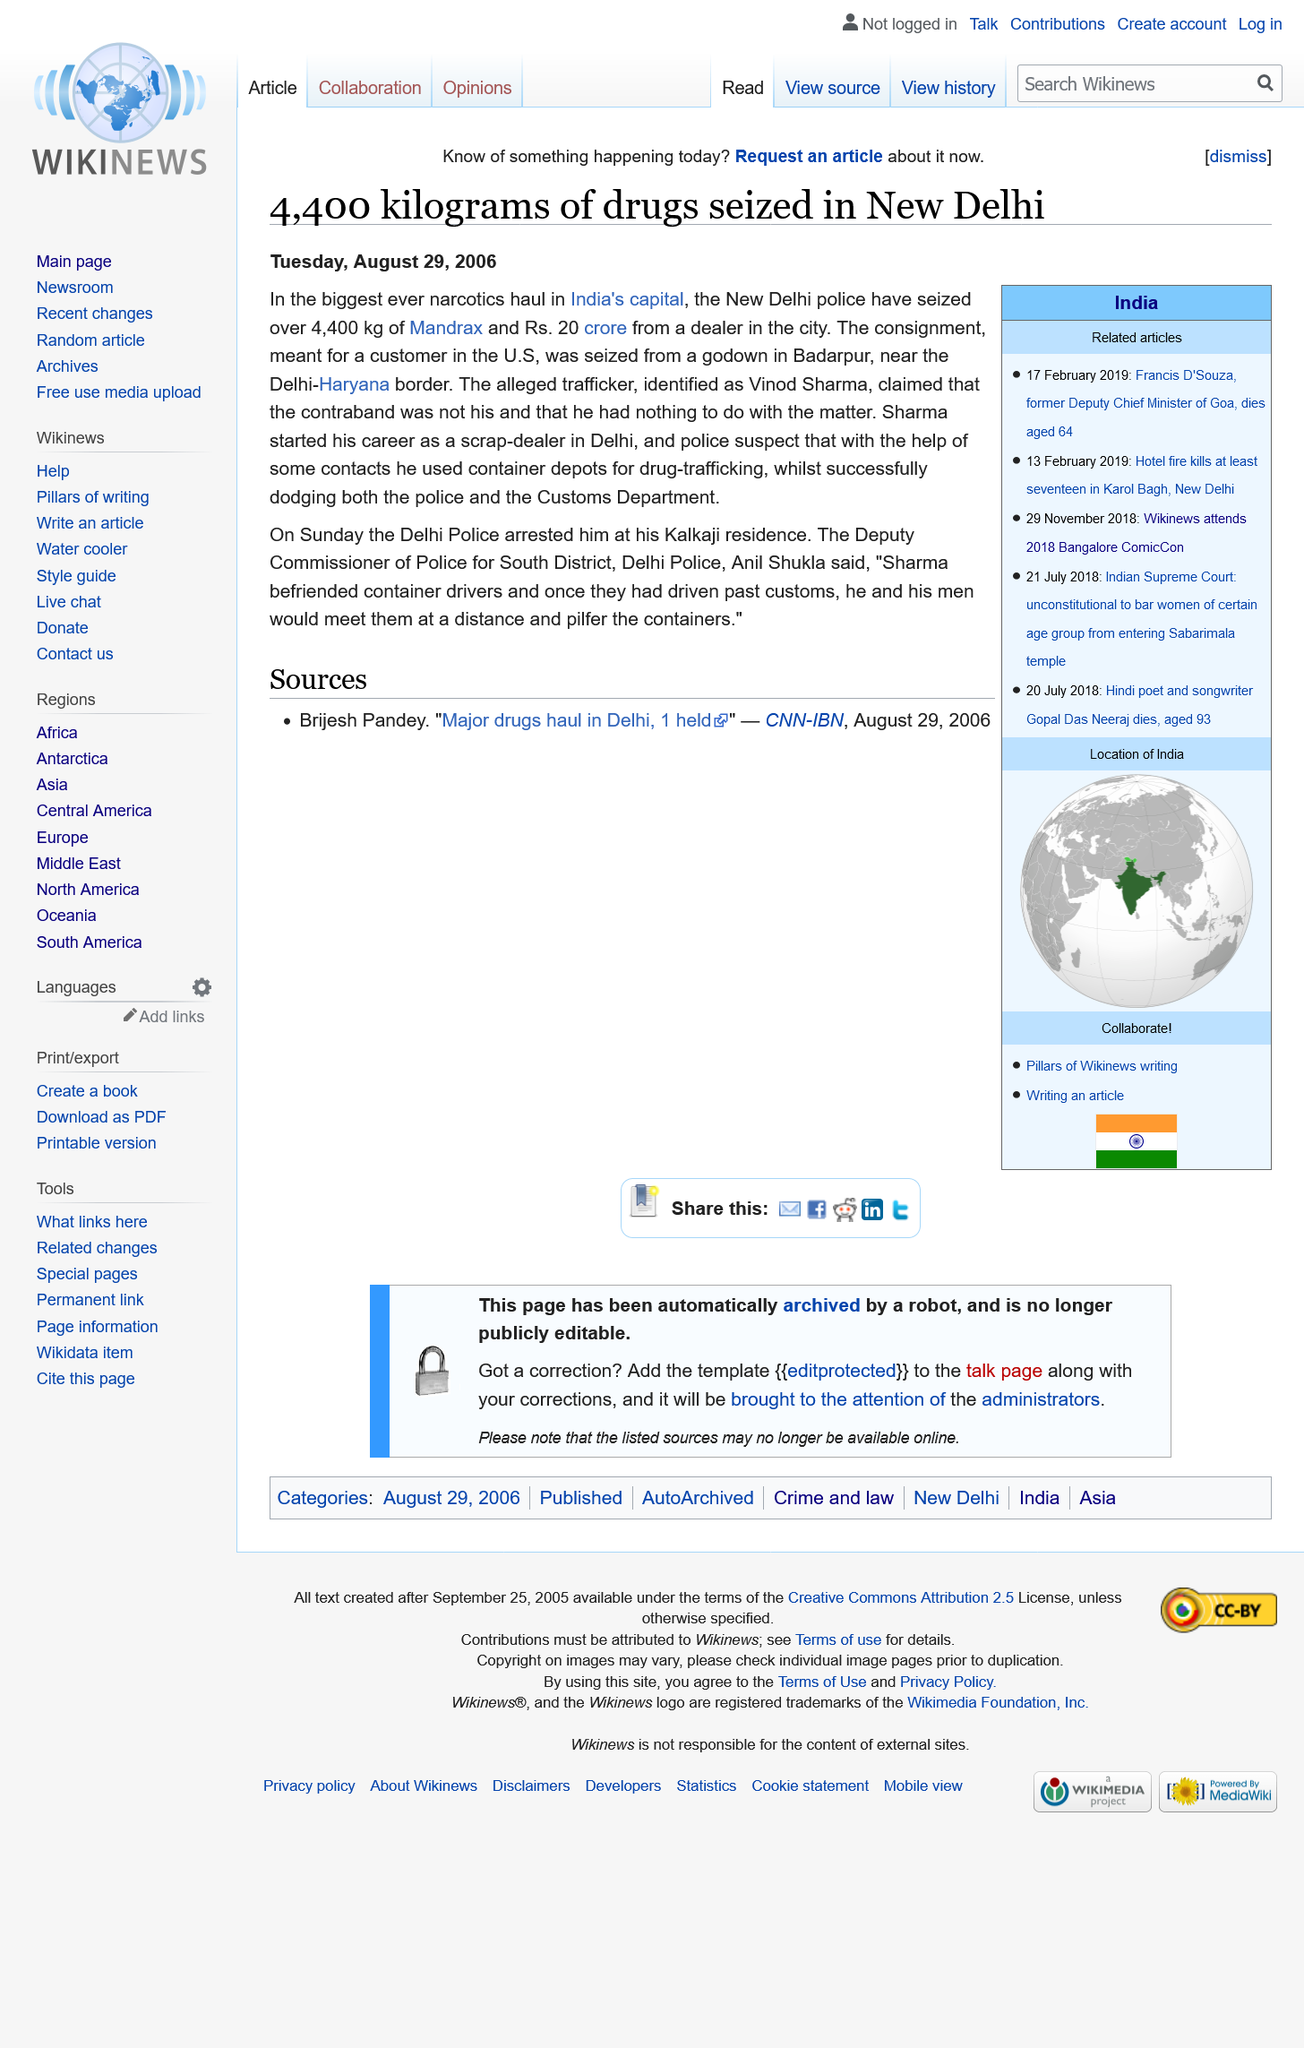Outline some significant characteristics in this image. The article mentions the names of the alleged perpetrators being held as Vinod Sharma. The report came out on the second day after the crime in terms of ordinal numbers. The accomplices to Sharma's alleged drug-trafficking scheme were the container drivers. 